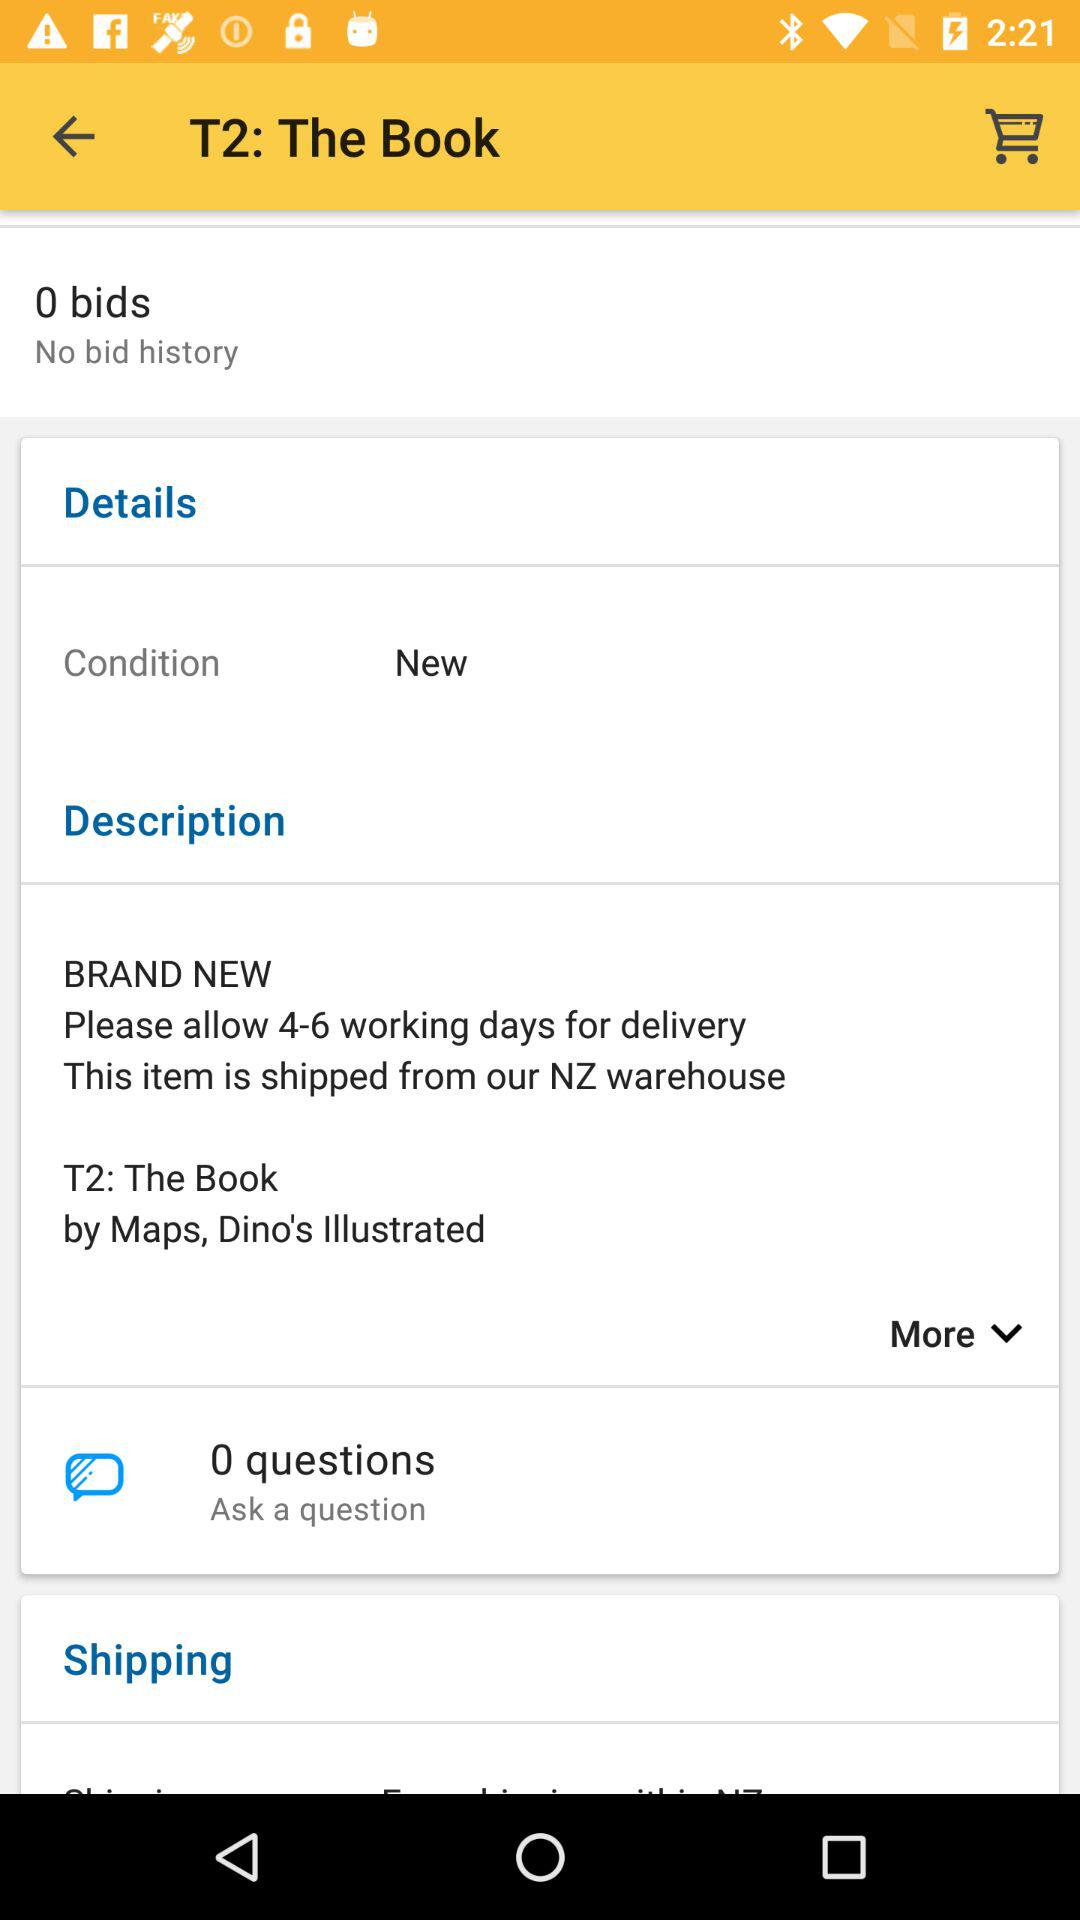How many questions are in the "Ask a Question" option? There are 0 questions. 